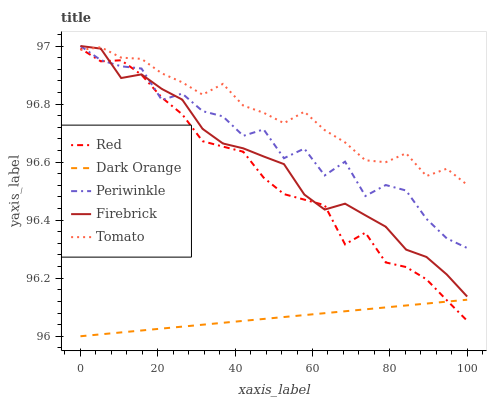Does Dark Orange have the minimum area under the curve?
Answer yes or no. Yes. Does Tomato have the maximum area under the curve?
Answer yes or no. Yes. Does Firebrick have the minimum area under the curve?
Answer yes or no. No. Does Firebrick have the maximum area under the curve?
Answer yes or no. No. Is Dark Orange the smoothest?
Answer yes or no. Yes. Is Periwinkle the roughest?
Answer yes or no. Yes. Is Firebrick the smoothest?
Answer yes or no. No. Is Firebrick the roughest?
Answer yes or no. No. Does Firebrick have the lowest value?
Answer yes or no. No. Does Periwinkle have the highest value?
Answer yes or no. Yes. Does Dark Orange have the highest value?
Answer yes or no. No. Is Dark Orange less than Tomato?
Answer yes or no. Yes. Is Periwinkle greater than Dark Orange?
Answer yes or no. Yes. Does Tomato intersect Firebrick?
Answer yes or no. Yes. Is Tomato less than Firebrick?
Answer yes or no. No. Is Tomato greater than Firebrick?
Answer yes or no. No. Does Dark Orange intersect Tomato?
Answer yes or no. No. 